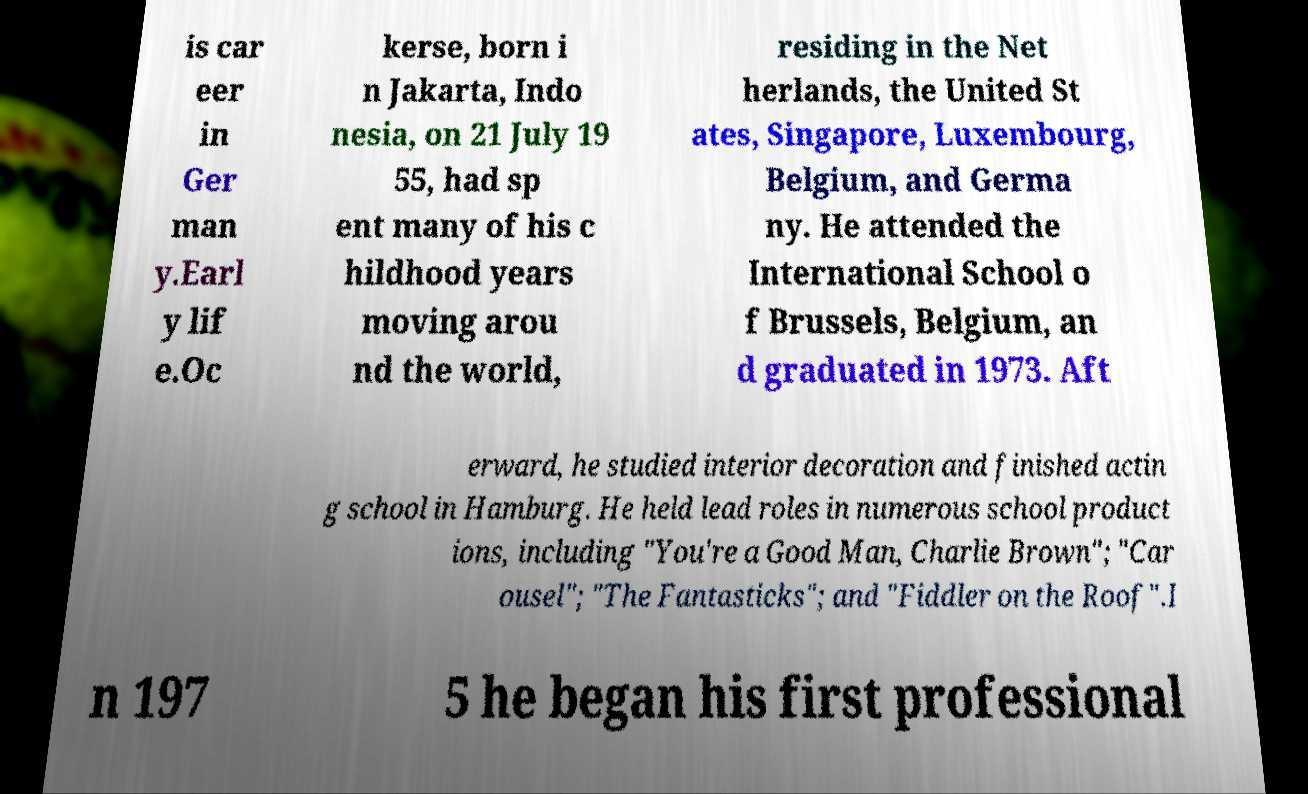What messages or text are displayed in this image? I need them in a readable, typed format. is car eer in Ger man y.Earl y lif e.Oc kerse, born i n Jakarta, Indo nesia, on 21 July 19 55, had sp ent many of his c hildhood years moving arou nd the world, residing in the Net herlands, the United St ates, Singapore, Luxembourg, Belgium, and Germa ny. He attended the International School o f Brussels, Belgium, an d graduated in 1973. Aft erward, he studied interior decoration and finished actin g school in Hamburg. He held lead roles in numerous school product ions, including "You're a Good Man, Charlie Brown"; "Car ousel"; "The Fantasticks"; and "Fiddler on the Roof".I n 197 5 he began his first professional 